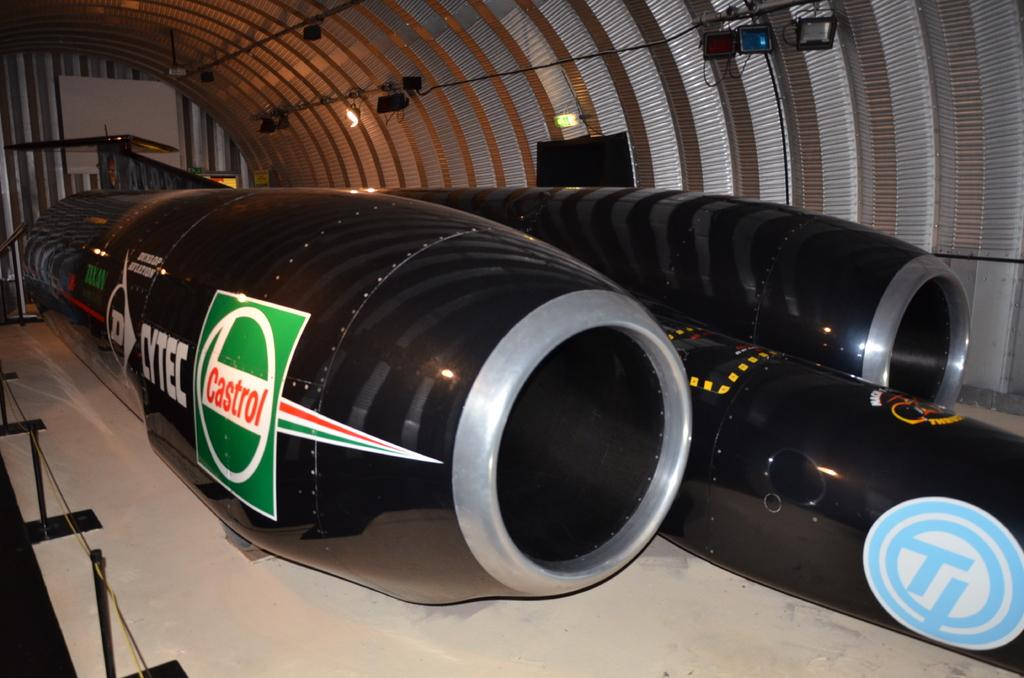<image>
Summarize the visual content of the image. An airplane in a hanger sponsored by Castrol and Cytec. 